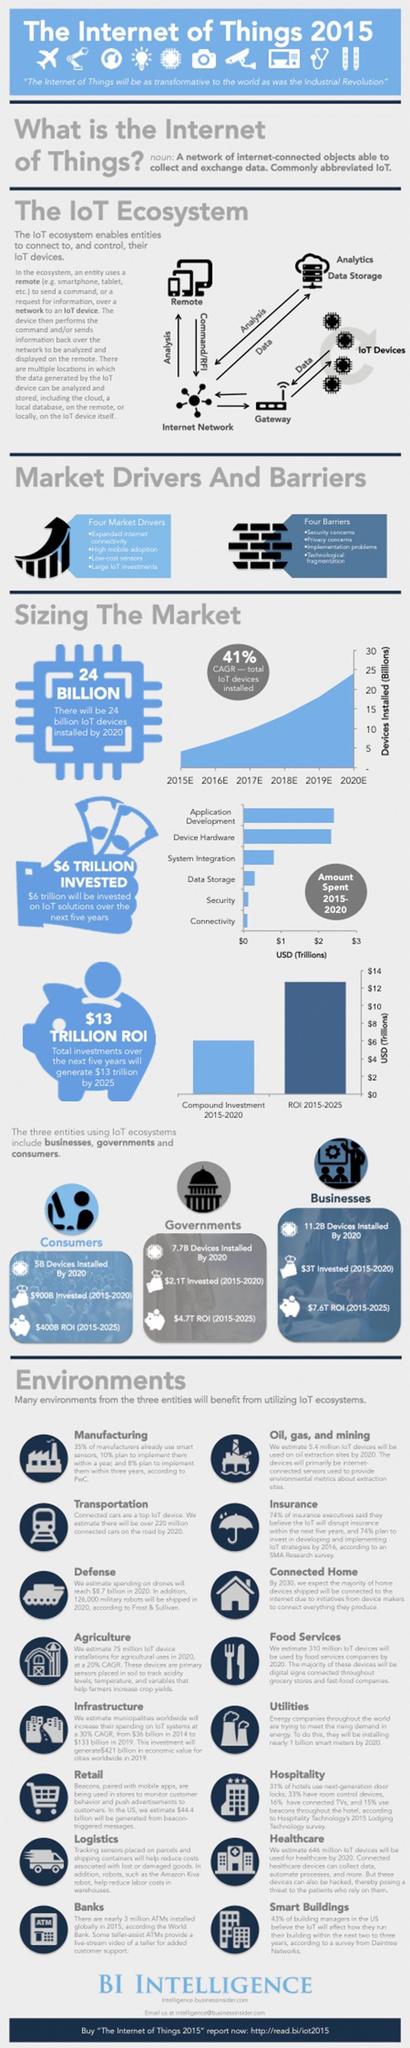What is the ROI of Internet of Things on businesses during 2015-2020?
Answer the question with a short phrase. $7.6T ROI How much money is invested on IoT solutions by the businesses during 2015-2020? $3T How many IoT devices will be installed in the government sector by 2020? 7.7B 